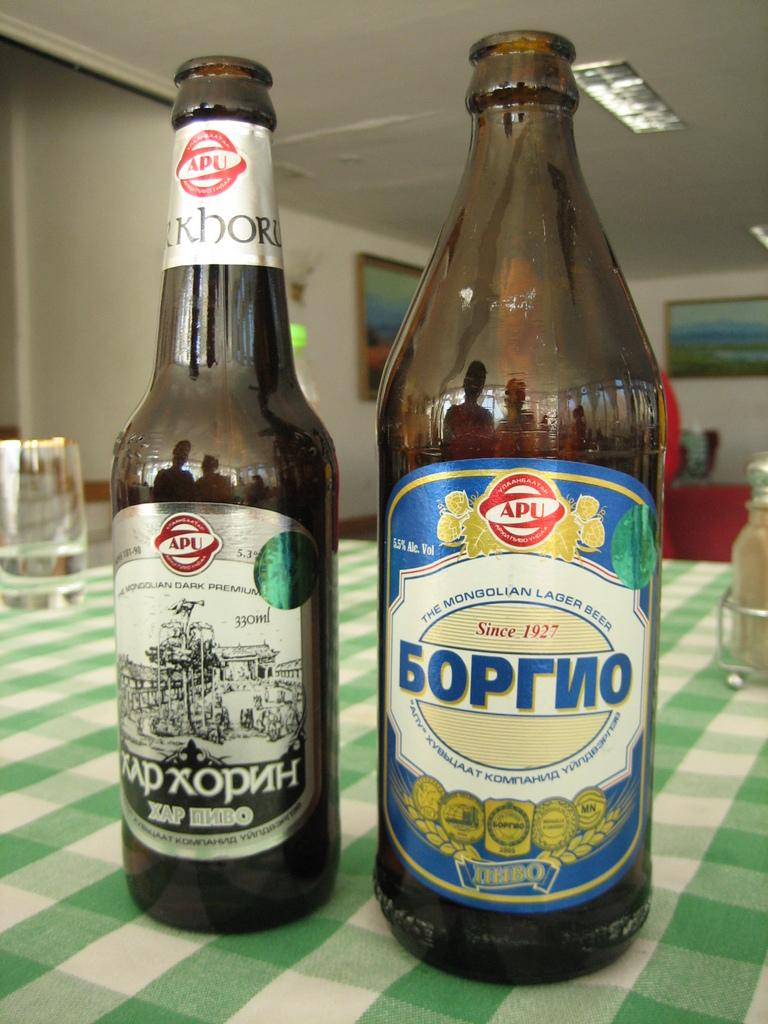What type of items have stickers on them in the image? There are two bottles with stickers in the image. What other container is visible in the image? There is a glass in the image. What is the third container in the image? There is a jar in the image. On what surface are the containers placed? The items are placed on a cloth. What can be seen in the background of the image? There are frames on the wall in the background of the image. What type of rod is used to hold the secretary's papers in the image? There is no rod or secretary present in the image; it only features bottles, a glass, a jar, a cloth, and frames on the wall. 